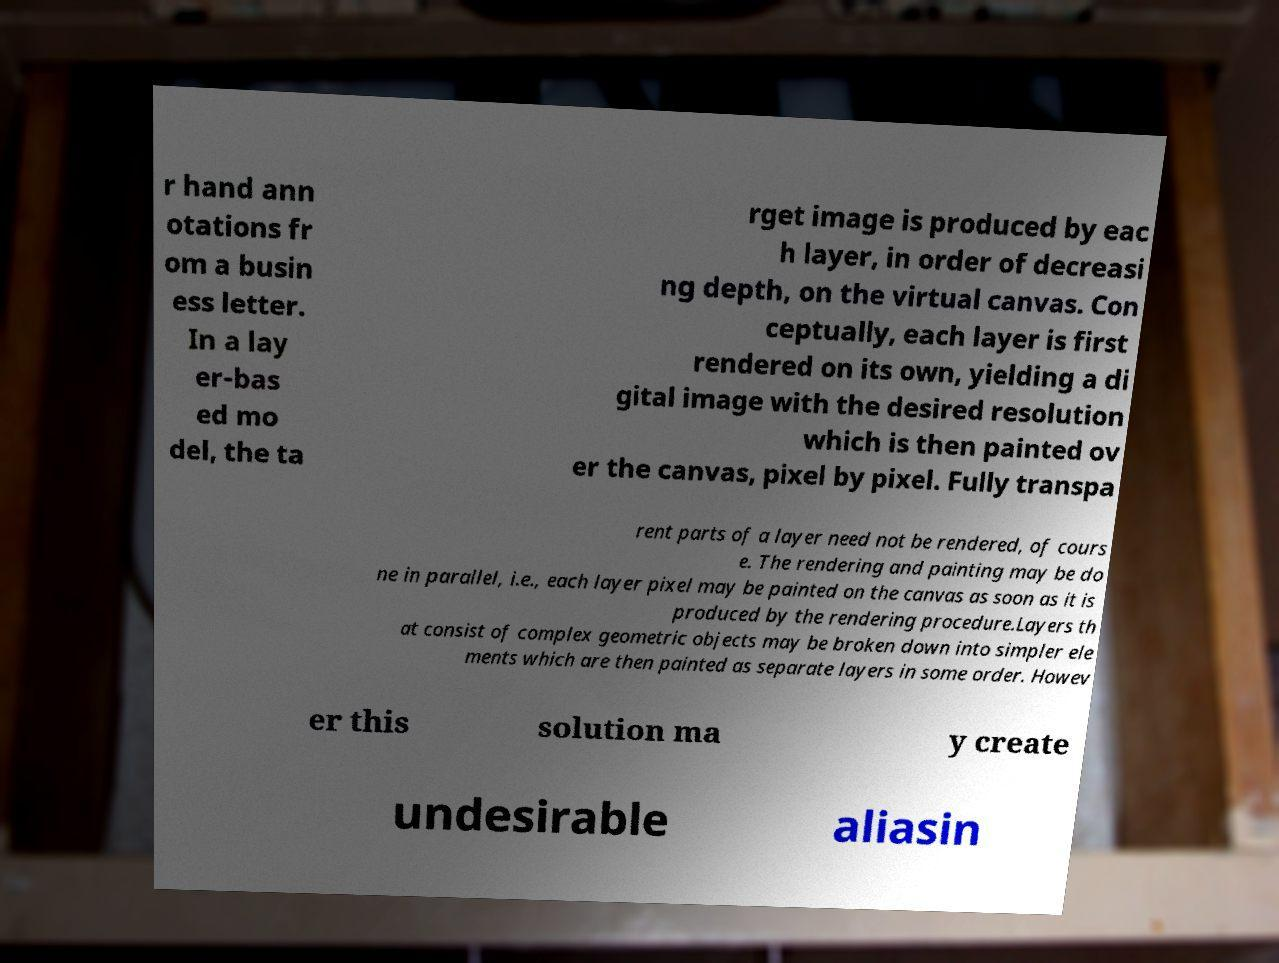Could you assist in decoding the text presented in this image and type it out clearly? r hand ann otations fr om a busin ess letter. In a lay er-bas ed mo del, the ta rget image is produced by eac h layer, in order of decreasi ng depth, on the virtual canvas. Con ceptually, each layer is first rendered on its own, yielding a di gital image with the desired resolution which is then painted ov er the canvas, pixel by pixel. Fully transpa rent parts of a layer need not be rendered, of cours e. The rendering and painting may be do ne in parallel, i.e., each layer pixel may be painted on the canvas as soon as it is produced by the rendering procedure.Layers th at consist of complex geometric objects may be broken down into simpler ele ments which are then painted as separate layers in some order. Howev er this solution ma y create undesirable aliasin 